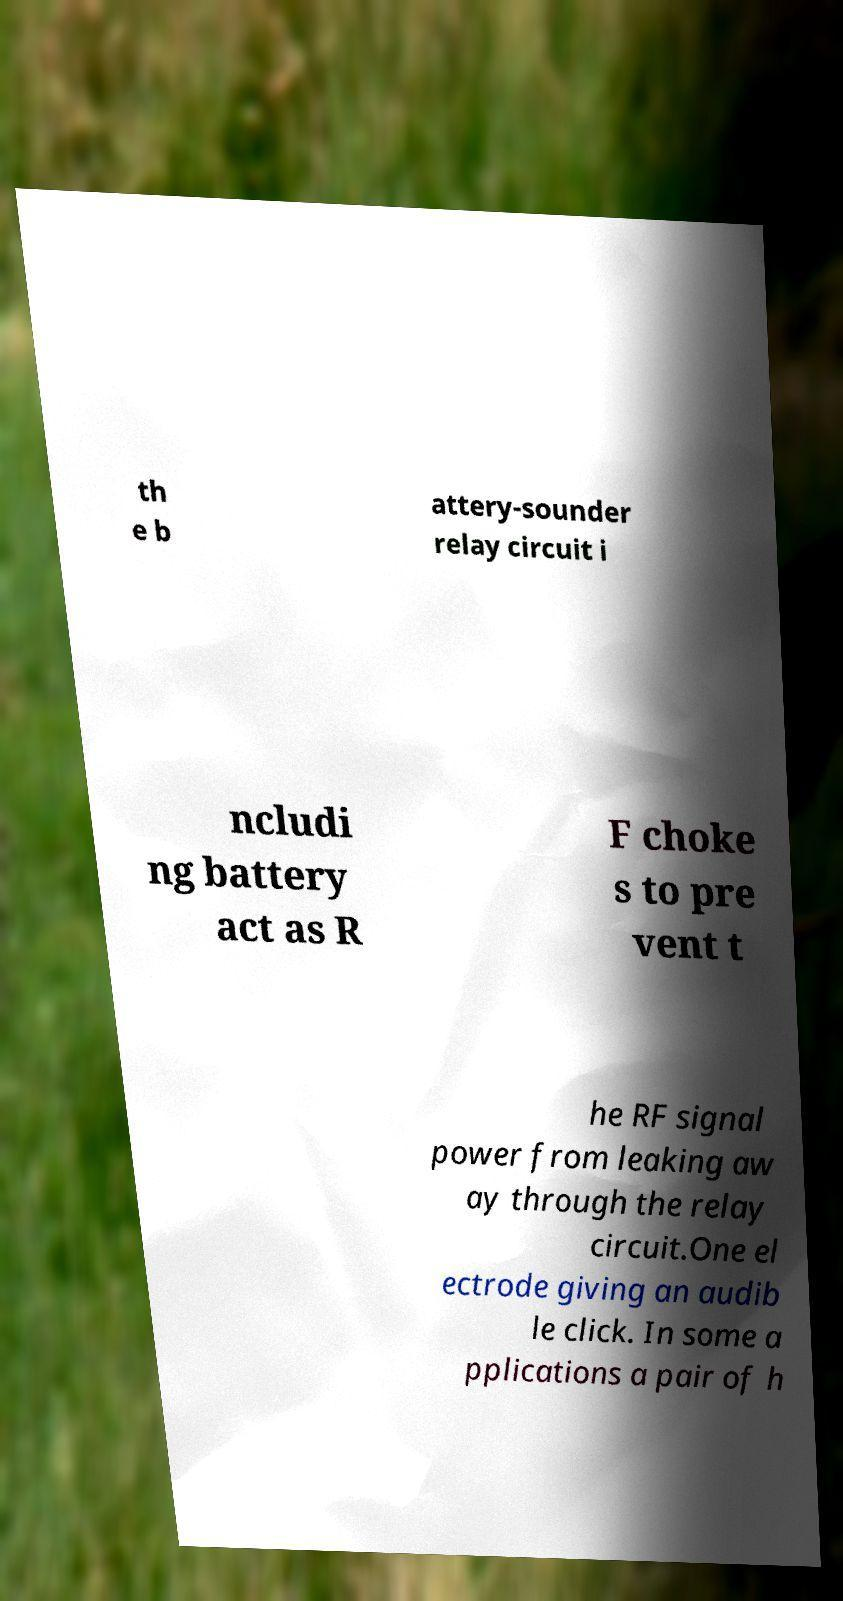Could you assist in decoding the text presented in this image and type it out clearly? th e b attery-sounder relay circuit i ncludi ng battery act as R F choke s to pre vent t he RF signal power from leaking aw ay through the relay circuit.One el ectrode giving an audib le click. In some a pplications a pair of h 